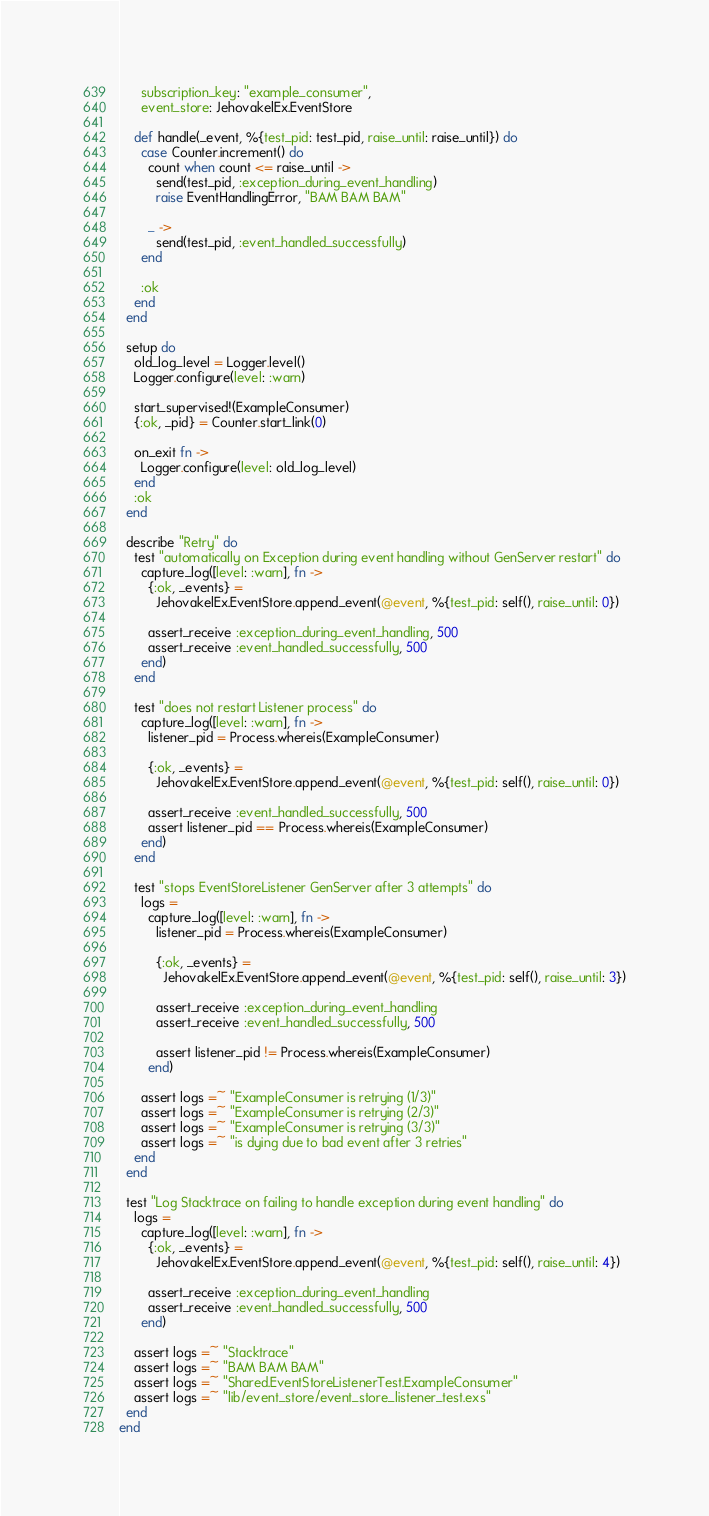<code> <loc_0><loc_0><loc_500><loc_500><_Elixir_>      subscription_key: "example_consumer",
      event_store: JehovakelEx.EventStore

    def handle(_event, %{test_pid: test_pid, raise_until: raise_until}) do
      case Counter.increment() do
        count when count <= raise_until ->
          send(test_pid, :exception_during_event_handling)
          raise EventHandlingError, "BAM BAM BAM"

        _ ->
          send(test_pid, :event_handled_successfully)
      end

      :ok
    end
  end

  setup do
    old_log_level = Logger.level()
    Logger.configure(level: :warn)

    start_supervised!(ExampleConsumer)
    {:ok, _pid} = Counter.start_link(0)

    on_exit fn ->
      Logger.configure(level: old_log_level)
    end
    :ok
  end

  describe "Retry" do
    test "automatically on Exception during event handling without GenServer restart" do
      capture_log([level: :warn], fn ->
        {:ok, _events} =
          JehovakelEx.EventStore.append_event(@event, %{test_pid: self(), raise_until: 0})

        assert_receive :exception_during_event_handling, 500
        assert_receive :event_handled_successfully, 500
      end)
    end

    test "does not restart Listener process" do
      capture_log([level: :warn], fn ->
        listener_pid = Process.whereis(ExampleConsumer)

        {:ok, _events} =
          JehovakelEx.EventStore.append_event(@event, %{test_pid: self(), raise_until: 0})

        assert_receive :event_handled_successfully, 500
        assert listener_pid == Process.whereis(ExampleConsumer)
      end)
    end

    test "stops EventStoreListener GenServer after 3 attempts" do
      logs =
        capture_log([level: :warn], fn ->
          listener_pid = Process.whereis(ExampleConsumer)

          {:ok, _events} =
            JehovakelEx.EventStore.append_event(@event, %{test_pid: self(), raise_until: 3})

          assert_receive :exception_during_event_handling
          assert_receive :event_handled_successfully, 500

          assert listener_pid != Process.whereis(ExampleConsumer)
        end)

      assert logs =~ "ExampleConsumer is retrying (1/3)"
      assert logs =~ "ExampleConsumer is retrying (2/3)"
      assert logs =~ "ExampleConsumer is retrying (3/3)"
      assert logs =~ "is dying due to bad event after 3 retries"
    end
  end

  test "Log Stacktrace on failing to handle exception during event handling" do
    logs =
      capture_log([level: :warn], fn ->
        {:ok, _events} =
          JehovakelEx.EventStore.append_event(@event, %{test_pid: self(), raise_until: 4})

        assert_receive :exception_during_event_handling
        assert_receive :event_handled_successfully, 500
      end)

    assert logs =~ "Stacktrace"
    assert logs =~ "BAM BAM BAM"
    assert logs =~ "Shared.EventStoreListenerTest.ExampleConsumer"
    assert logs =~ "lib/event_store/event_store_listener_test.exs"
  end
end
</code> 